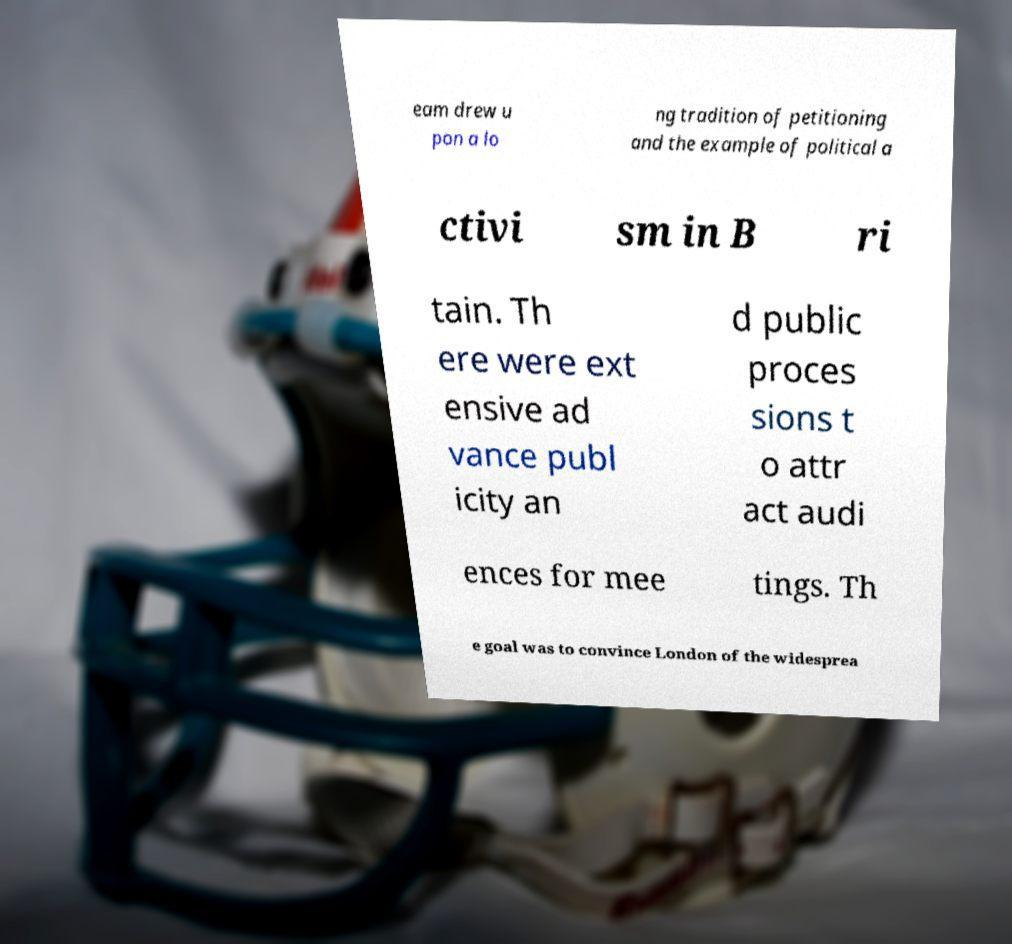Please identify and transcribe the text found in this image. eam drew u pon a lo ng tradition of petitioning and the example of political a ctivi sm in B ri tain. Th ere were ext ensive ad vance publ icity an d public proces sions t o attr act audi ences for mee tings. Th e goal was to convince London of the widesprea 